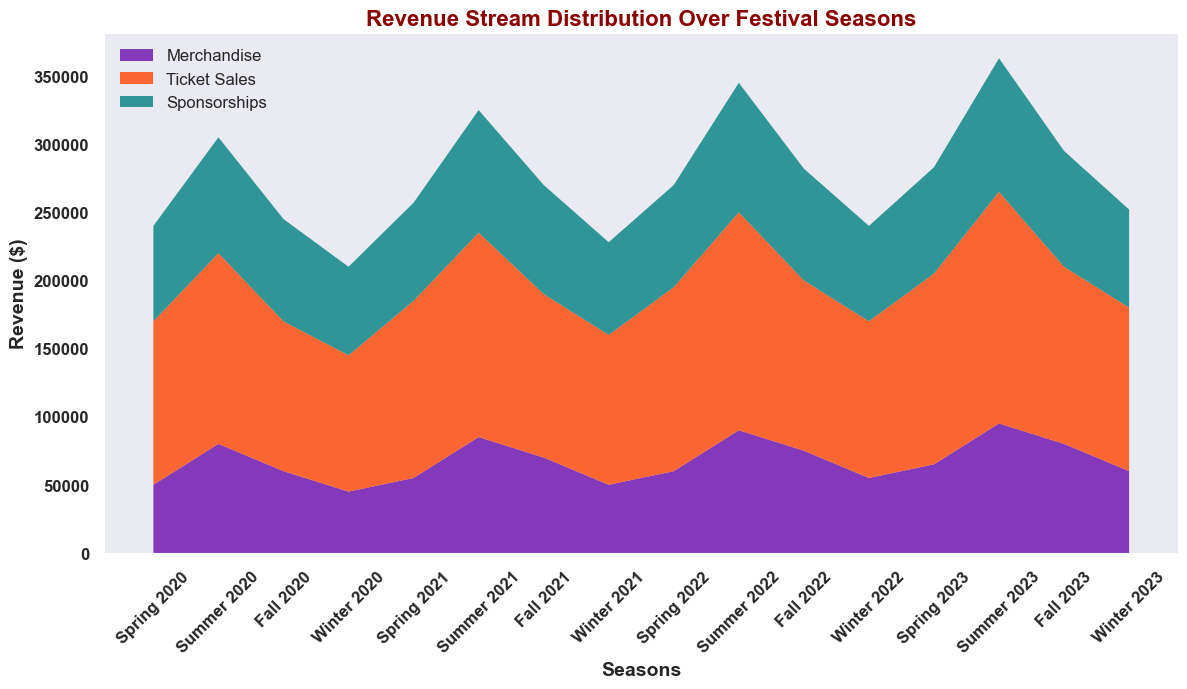Which season saw the highest revenue from merchandise? Observing the different segments of the area chart, the height of the purple section (merchandise) is greatest during the Summer 2023 season.
Answer: Summer 2023 How does the revenue from sponsorships in Winter 2022 compare to Winter 2023? The green section at Winter 2022 is shorter compared to the green section at Winter 2023. This indicates that sponsorship revenue was higher in Winter 2023.
Answer: Winter 2023 has higher sponsorship revenue What is the total revenue across all streams in Fall 2020? To find the total, sum the heights of all three sections (merchandise: 60,000, ticket sales: 110,000, sponsorships: 75,000). The total is 60,000 + 110,000 + 75,000 = 245,000.
Answer: 245,000 Which season had the lowest ticket sales, and what is that value? The height of the orange section for ticket sales is smallest in Winter 2020, with the value stated as 100,000.
Answer: Winter 2020, 100,000 In which season did merchandise revenue first exceed 70,000? The purple section first exceeds 70,000 in Summer 2020.
Answer: Summer 2020 Compare the merchandise revenue between Spring 2022 and Spring 2023. In Spring 2022, the purple section represents 60,000 while in Spring 2023, it represents 65,000. Hence, merchandise revenue increased in Spring 2023.
Answer: Spring 2023 has higher merchandise revenue What is the cumulative revenue from ticket sales over all seasons? By summing the values of ticket sales from each season: 120,000 + 140,000 + 110,000 + 100,000 + 130,000 + 150,000 + 120,000 + 110,000 + 135,000 + 160,000 + 125,000 + 115,000 + 140,000 + 170,000 + 130,000 + 120,000 = 1,875,000.
Answer: 1,875,000 Which revenue stream showed the most growth between Winter 2020 and Summer 2023? By observing the visual segments, merchandise grew from 45,000 in Winter 2020 to 95,000 in Summer 2023, ticket sales from 100,000 to 170,000, and sponsorships from 65,000 to 98,000. The relative growth is largest for ticket sales (70,000 increase).
Answer: Ticket Sales What is the average revenue from sponsorships in the year 2021? Sum the sponsorship revenues for 2021 (72,000 + 90,000 + 80,000 + 68,000) and divide by 4. The calculation is (72,000 + 90,000 + 80,000 + 68,000) / 4 = 77,500.
Answer: 77,500 During which season does the total revenue first surpass 400,000? By adding the revenues for each section each season, it first surpasses 400,000 in Summer 2022 (90,000 merchandise + 160,000 ticket sales + 95,000 sponsorships = 345,000). The total for Winter 2022 keeps it below 400,000, but Summer 2023 is (95,000 merchandise + 170,000 ticket sales + 98,000 sponsorships = 363,000). So none of the seasons surpass 400,000.
Answer: None 